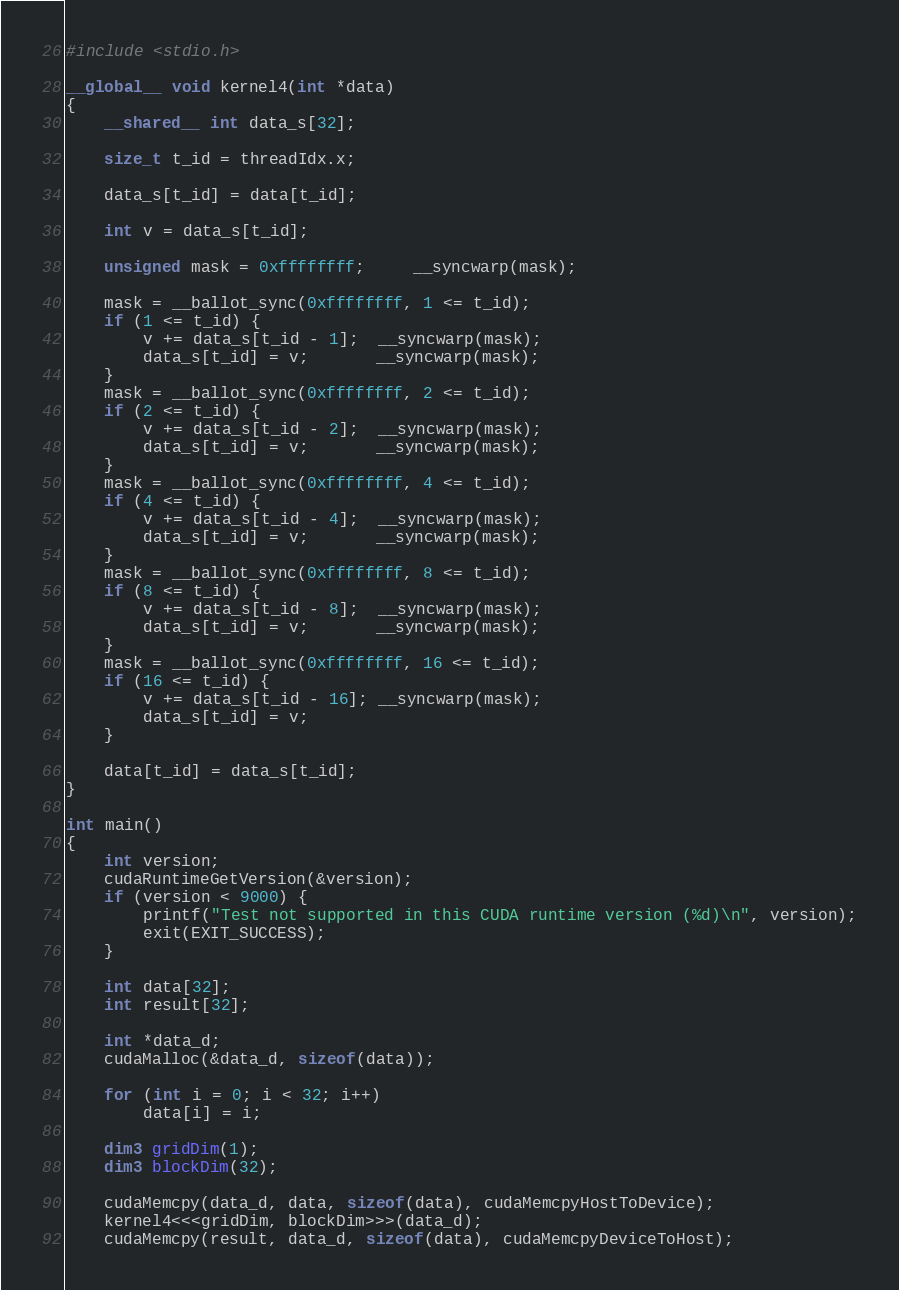Convert code to text. <code><loc_0><loc_0><loc_500><loc_500><_Cuda_>#include <stdio.h>

__global__ void kernel4(int *data)
{
	__shared__ int data_s[32];

	size_t t_id = threadIdx.x;

	data_s[t_id] = data[t_id];

	int v = data_s[t_id];

	unsigned mask = 0xffffffff;     __syncwarp(mask);

	mask = __ballot_sync(0xffffffff, 1 <= t_id);
	if (1 <= t_id) {
		v += data_s[t_id - 1];  __syncwarp(mask);
		data_s[t_id] = v;       __syncwarp(mask);
	}
	mask = __ballot_sync(0xffffffff, 2 <= t_id);
	if (2 <= t_id) {
		v += data_s[t_id - 2];  __syncwarp(mask);
		data_s[t_id] = v;       __syncwarp(mask);
	}
	mask = __ballot_sync(0xffffffff, 4 <= t_id);
	if (4 <= t_id) {
		v += data_s[t_id - 4];  __syncwarp(mask);
		data_s[t_id] = v;       __syncwarp(mask);
	}
	mask = __ballot_sync(0xffffffff, 8 <= t_id);
	if (8 <= t_id) {
		v += data_s[t_id - 8];  __syncwarp(mask);
		data_s[t_id] = v;       __syncwarp(mask);
	}
	mask = __ballot_sync(0xffffffff, 16 <= t_id);
	if (16 <= t_id) {
		v += data_s[t_id - 16]; __syncwarp(mask);
		data_s[t_id] = v;
	}

	data[t_id] = data_s[t_id];
}

int main()
{
	int version;
	cudaRuntimeGetVersion(&version);
	if (version < 9000) {
		printf("Test not supported in this CUDA runtime version (%d)\n", version);
		exit(EXIT_SUCCESS);
	}

	int data[32];
	int result[32];

	int *data_d;
	cudaMalloc(&data_d, sizeof(data));

	for (int i = 0; i < 32; i++)
		data[i] = i;

	dim3 gridDim(1);
	dim3 blockDim(32);

	cudaMemcpy(data_d, data, sizeof(data), cudaMemcpyHostToDevice);
	kernel4<<<gridDim, blockDim>>>(data_d);
	cudaMemcpy(result, data_d, sizeof(data), cudaMemcpyDeviceToHost);
</code> 